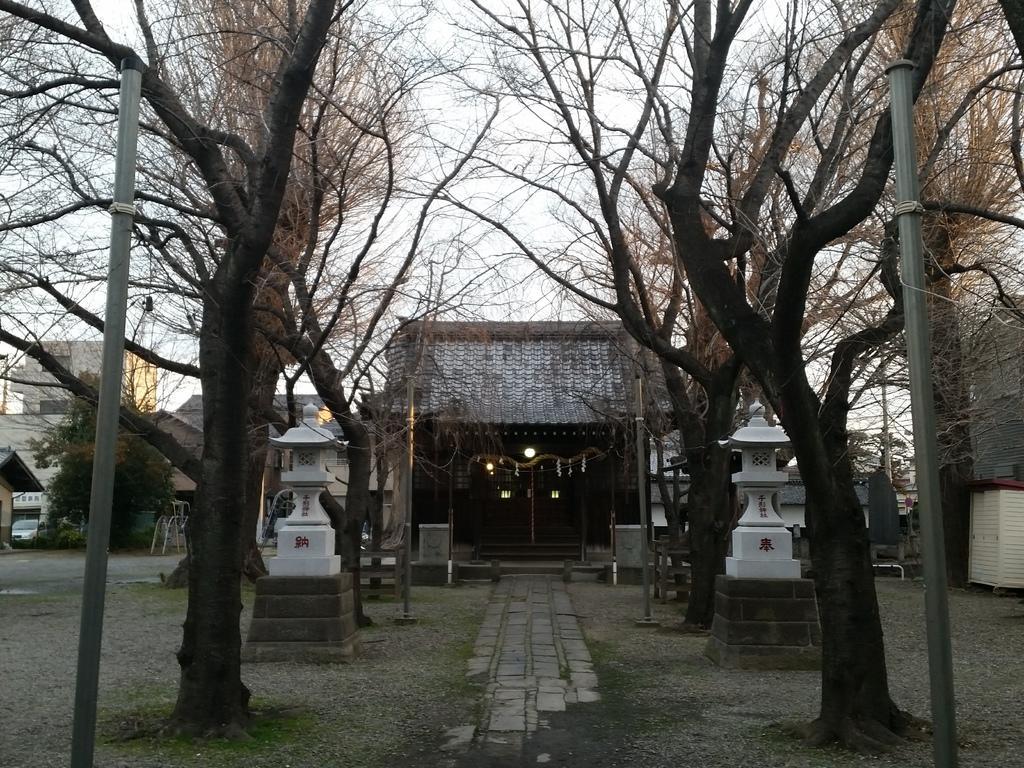Please provide a concise description of this image. In this image there is a path, on either side of the path there are trees, poles and sculptures, in the background there are houses and the sky. 